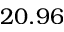<formula> <loc_0><loc_0><loc_500><loc_500>2 0 . 9 6</formula> 